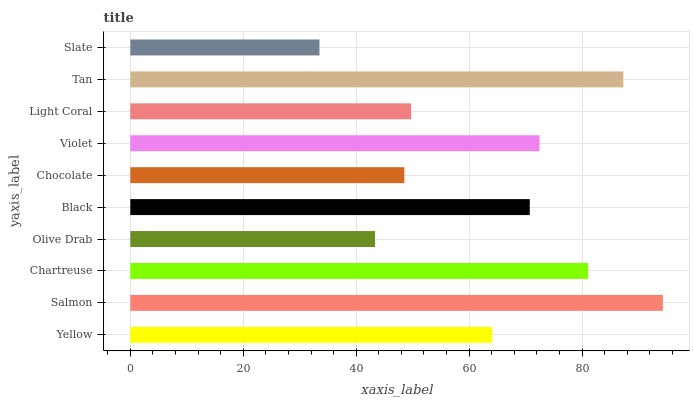Is Slate the minimum?
Answer yes or no. Yes. Is Salmon the maximum?
Answer yes or no. Yes. Is Chartreuse the minimum?
Answer yes or no. No. Is Chartreuse the maximum?
Answer yes or no. No. Is Salmon greater than Chartreuse?
Answer yes or no. Yes. Is Chartreuse less than Salmon?
Answer yes or no. Yes. Is Chartreuse greater than Salmon?
Answer yes or no. No. Is Salmon less than Chartreuse?
Answer yes or no. No. Is Black the high median?
Answer yes or no. Yes. Is Yellow the low median?
Answer yes or no. Yes. Is Salmon the high median?
Answer yes or no. No. Is Chartreuse the low median?
Answer yes or no. No. 